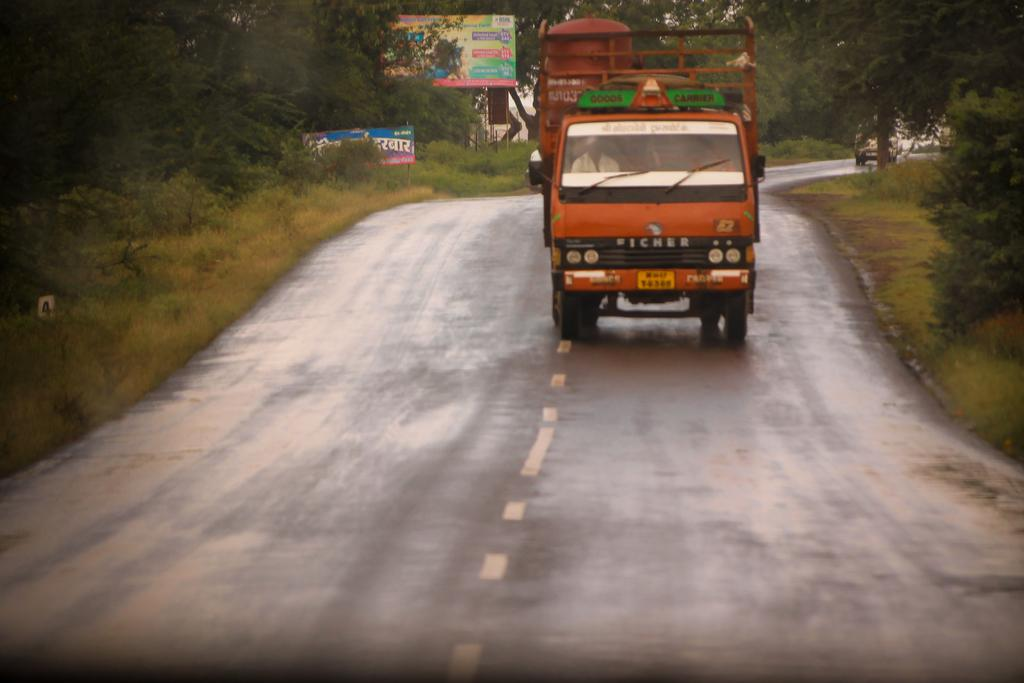What is the main subject of the image? There is a lorry in the image. What is the lorry doing in the image? The lorry is moving on the road. What can be seen on either side of the road? There are plants and trees on the ground on either side of the road. Can you see a wave of cherry trees in the image? There is no wave of cherry trees present in the image. What subject is the lorry teaching in the image? The lorry is not teaching any subject in the image; it is simply moving on the road. 